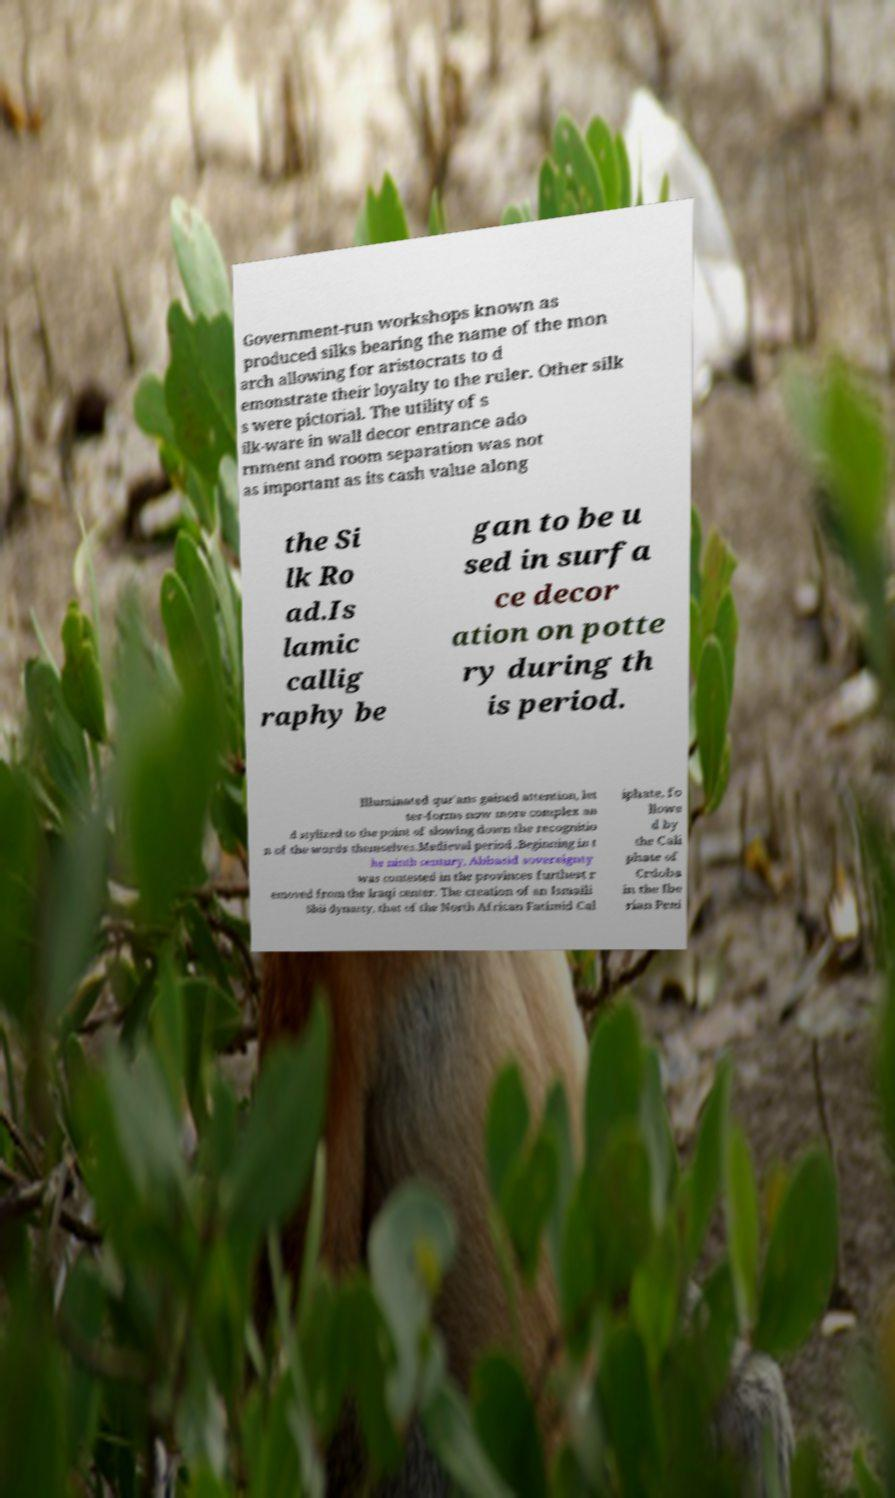Can you accurately transcribe the text from the provided image for me? Government-run workshops known as produced silks bearing the name of the mon arch allowing for aristocrats to d emonstrate their loyalty to the ruler. Other silk s were pictorial. The utility of s ilk-ware in wall decor entrance ado rnment and room separation was not as important as its cash value along the Si lk Ro ad.Is lamic callig raphy be gan to be u sed in surfa ce decor ation on potte ry during th is period. Illuminated qur'ans gained attention, let ter-forms now more complex an d stylized to the point of slowing down the recognitio n of the words themselves.Medieval period .Beginning in t he ninth century, Abbasid sovereignty was contested in the provinces furthest r emoved from the Iraqi center. The creation of an Ismaili Shii dynasty, that of the North African Fatimid Cal iphate, fo llowe d by the Cali phate of Crdoba in the Ibe rian Peni 